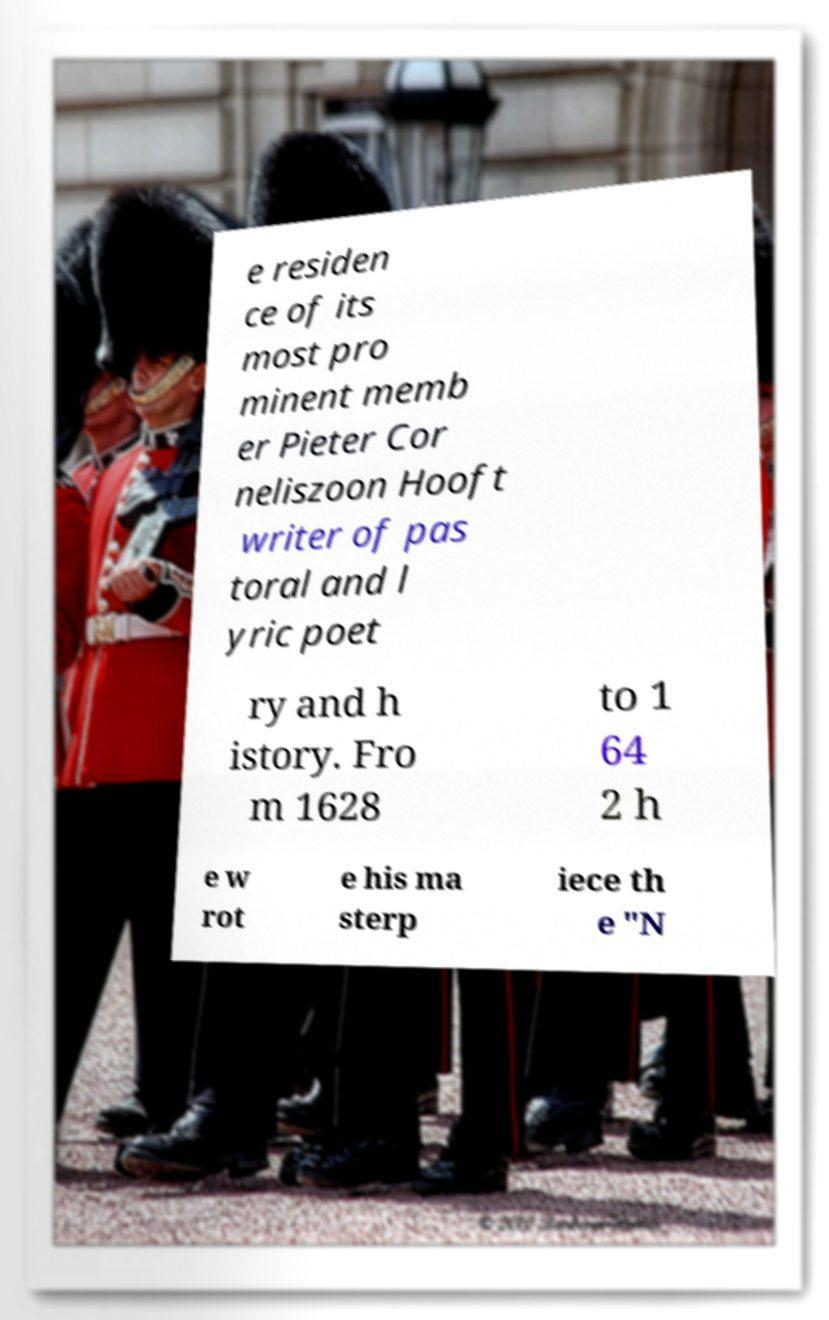Could you assist in decoding the text presented in this image and type it out clearly? e residen ce of its most pro minent memb er Pieter Cor neliszoon Hooft writer of pas toral and l yric poet ry and h istory. Fro m 1628 to 1 64 2 h e w rot e his ma sterp iece th e "N 